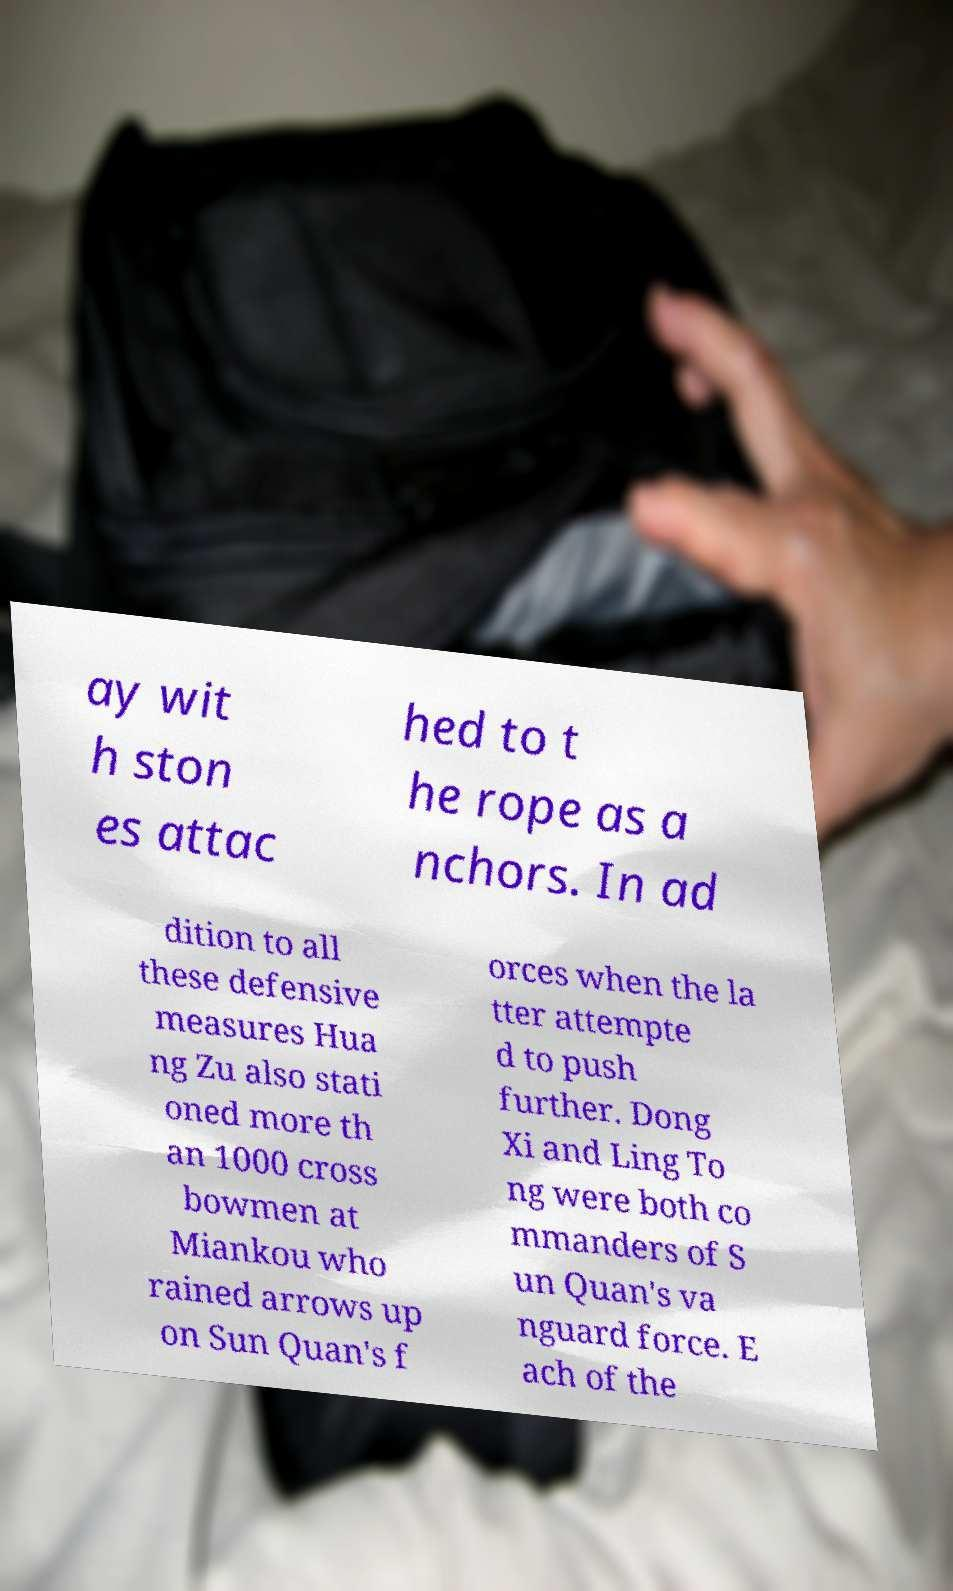Could you extract and type out the text from this image? ay wit h ston es attac hed to t he rope as a nchors. In ad dition to all these defensive measures Hua ng Zu also stati oned more th an 1000 cross bowmen at Miankou who rained arrows up on Sun Quan's f orces when the la tter attempte d to push further. Dong Xi and Ling To ng were both co mmanders of S un Quan's va nguard force. E ach of the 